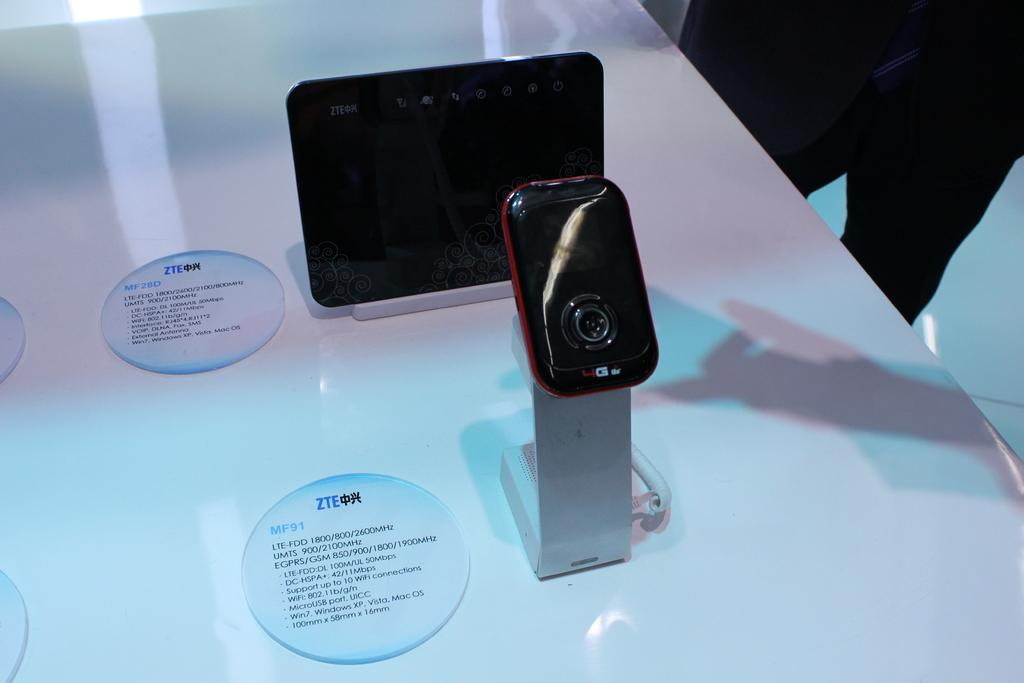<image>
Present a compact description of the photo's key features. A round tag with ZTE and MF91 is on the table next to the item on display. 